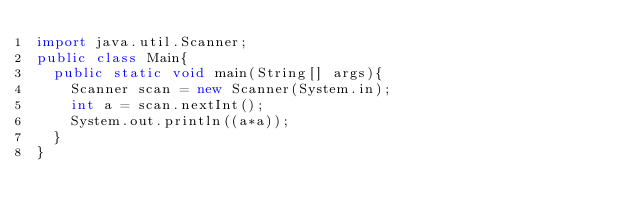<code> <loc_0><loc_0><loc_500><loc_500><_Java_>import java.util.Scanner;
public class Main{
  public static void main(String[] args){
    Scanner scan = new Scanner(System.in);
    int a = scan.nextInt();
    System.out.println((a*a));
  }
}</code> 